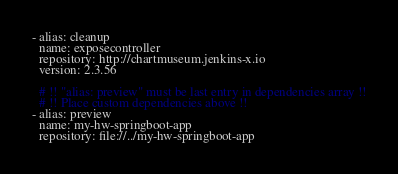Convert code to text. <code><loc_0><loc_0><loc_500><loc_500><_YAML_>- alias: cleanup
  name: exposecontroller
  repository: http://chartmuseum.jenkins-x.io
  version: 2.3.56

  # !! "alias: preview" must be last entry in dependencies array !!
  # !! Place custom dependencies above !!
- alias: preview
  name: my-hw-springboot-app
  repository: file://../my-hw-springboot-app
</code> 